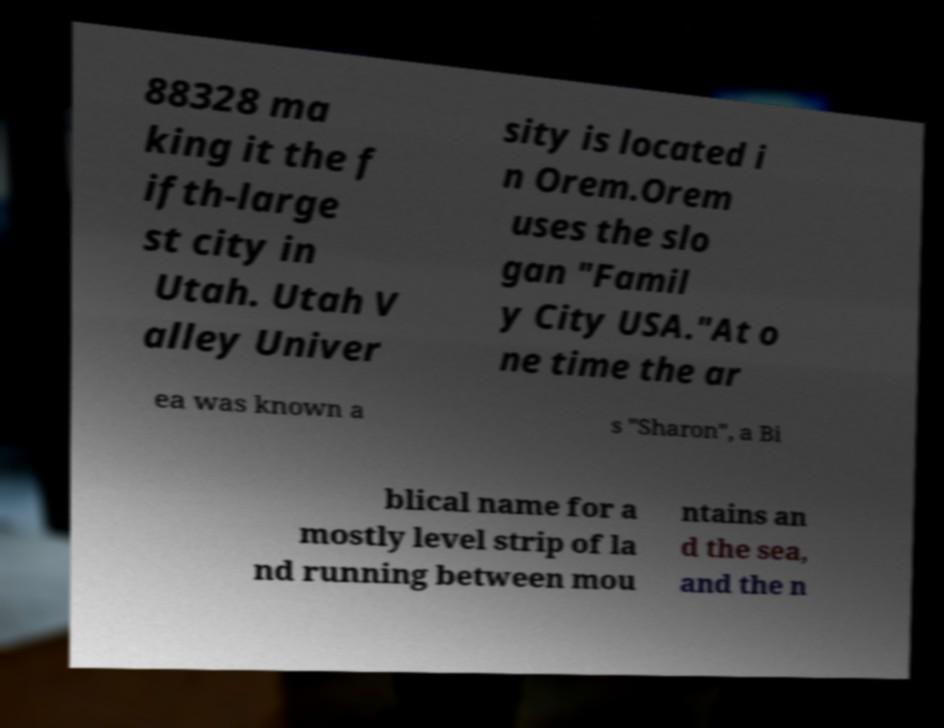I need the written content from this picture converted into text. Can you do that? 88328 ma king it the f ifth-large st city in Utah. Utah V alley Univer sity is located i n Orem.Orem uses the slo gan "Famil y City USA."At o ne time the ar ea was known a s "Sharon", a Bi blical name for a mostly level strip of la nd running between mou ntains an d the sea, and the n 